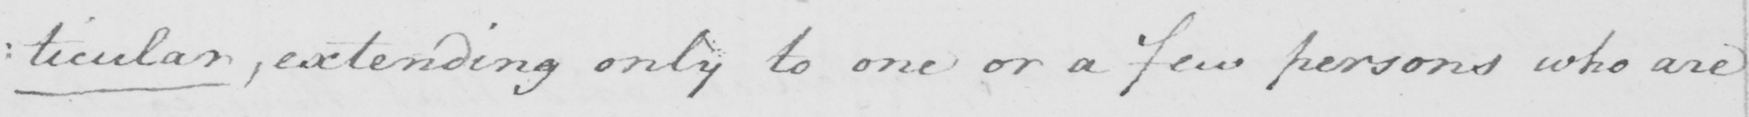Please provide the text content of this handwritten line. : ticular , extending only to one or a few persons who are 